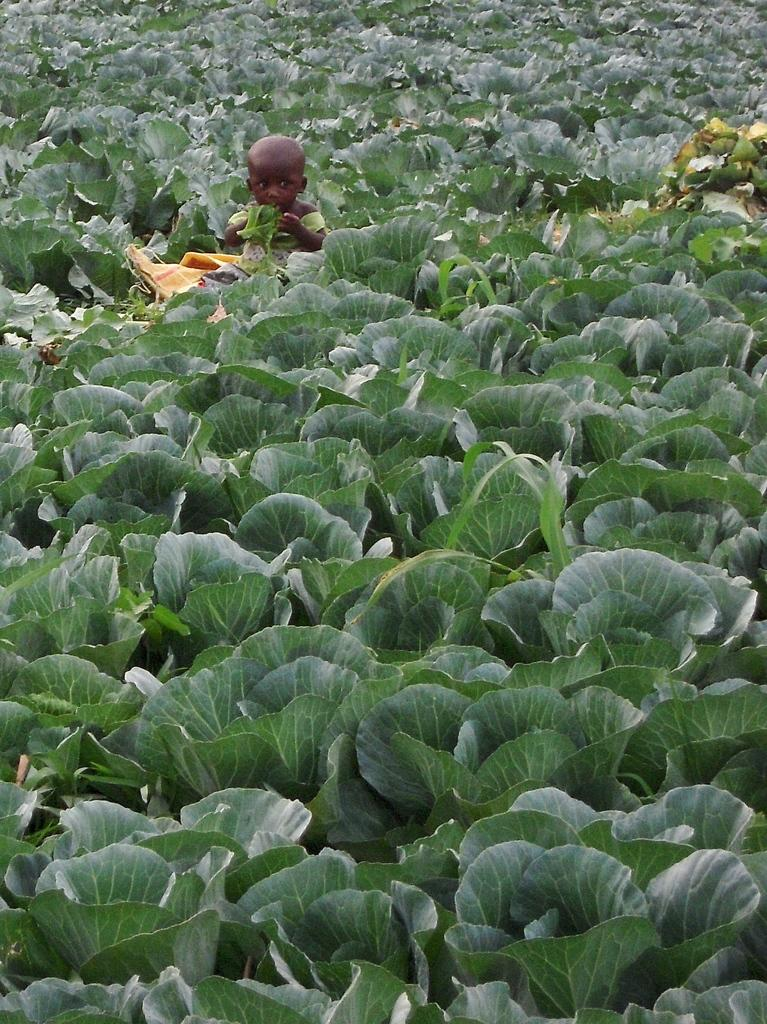What is the main subject of the image? The main subject of the image is a kid. Where is the kid located in the image? The kid is among plants in the image. What type of donkey can be seen interacting with the kid in the image? There is no donkey present in the image; it only features a kid among plants. What historical attraction is visible in the background of the image? There is no historical attraction visible in the image; it only features a kid among plants. 